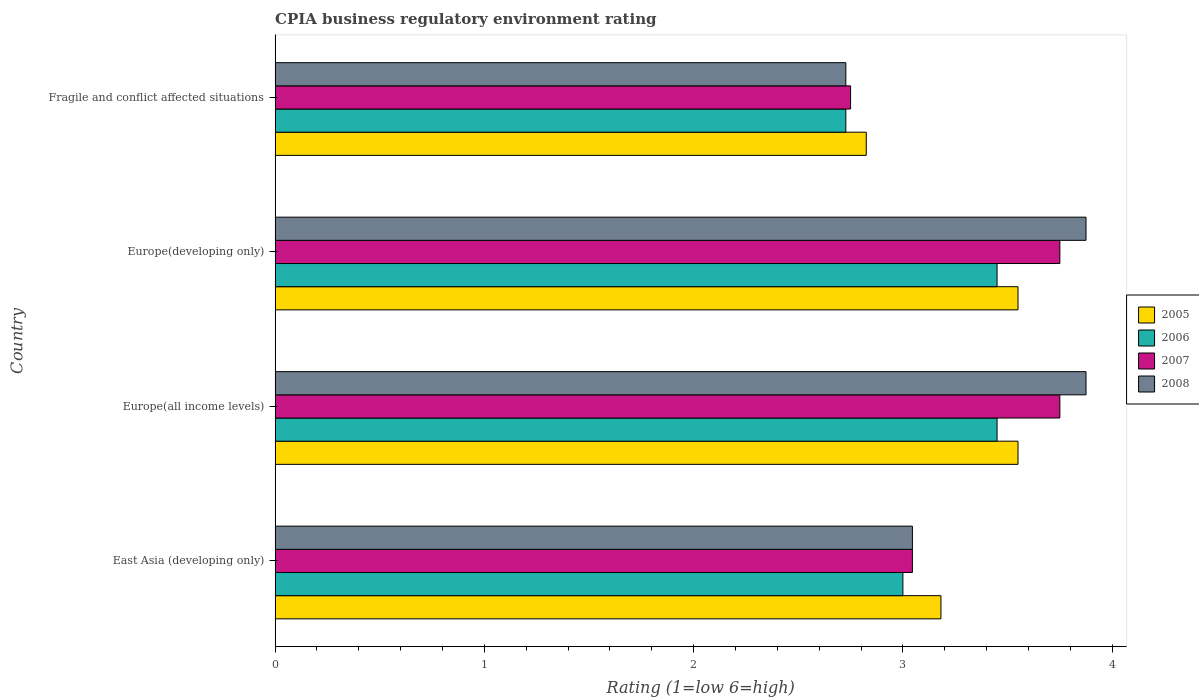How many different coloured bars are there?
Your response must be concise. 4. Are the number of bars on each tick of the Y-axis equal?
Offer a very short reply. Yes. What is the label of the 4th group of bars from the top?
Give a very brief answer. East Asia (developing only). In how many cases, is the number of bars for a given country not equal to the number of legend labels?
Ensure brevity in your answer.  0. What is the CPIA rating in 2008 in Europe(all income levels)?
Your response must be concise. 3.88. Across all countries, what is the maximum CPIA rating in 2007?
Provide a succinct answer. 3.75. Across all countries, what is the minimum CPIA rating in 2006?
Offer a terse response. 2.73. In which country was the CPIA rating in 2006 maximum?
Give a very brief answer. Europe(all income levels). In which country was the CPIA rating in 2005 minimum?
Your response must be concise. Fragile and conflict affected situations. What is the total CPIA rating in 2005 in the graph?
Ensure brevity in your answer.  13.11. What is the difference between the CPIA rating in 2008 in Europe(developing only) and that in Fragile and conflict affected situations?
Your response must be concise. 1.15. What is the average CPIA rating in 2006 per country?
Provide a short and direct response. 3.16. What is the difference between the CPIA rating in 2006 and CPIA rating in 2007 in East Asia (developing only)?
Keep it short and to the point. -0.05. In how many countries, is the CPIA rating in 2005 greater than 3.6 ?
Provide a succinct answer. 0. What is the ratio of the CPIA rating in 2007 in East Asia (developing only) to that in Europe(developing only)?
Offer a terse response. 0.81. Is the difference between the CPIA rating in 2006 in East Asia (developing only) and Fragile and conflict affected situations greater than the difference between the CPIA rating in 2007 in East Asia (developing only) and Fragile and conflict affected situations?
Provide a succinct answer. No. What is the difference between the highest and the lowest CPIA rating in 2006?
Your answer should be compact. 0.72. In how many countries, is the CPIA rating in 2007 greater than the average CPIA rating in 2007 taken over all countries?
Provide a succinct answer. 2. Is the sum of the CPIA rating in 2008 in East Asia (developing only) and Europe(all income levels) greater than the maximum CPIA rating in 2006 across all countries?
Offer a terse response. Yes. What does the 3rd bar from the bottom in Fragile and conflict affected situations represents?
Ensure brevity in your answer.  2007. Is it the case that in every country, the sum of the CPIA rating in 2008 and CPIA rating in 2007 is greater than the CPIA rating in 2006?
Give a very brief answer. Yes. How many bars are there?
Your answer should be compact. 16. How many countries are there in the graph?
Ensure brevity in your answer.  4. Where does the legend appear in the graph?
Your answer should be very brief. Center right. How many legend labels are there?
Your answer should be very brief. 4. What is the title of the graph?
Provide a succinct answer. CPIA business regulatory environment rating. What is the label or title of the X-axis?
Your response must be concise. Rating (1=low 6=high). What is the Rating (1=low 6=high) in 2005 in East Asia (developing only)?
Offer a terse response. 3.18. What is the Rating (1=low 6=high) of 2007 in East Asia (developing only)?
Your response must be concise. 3.05. What is the Rating (1=low 6=high) in 2008 in East Asia (developing only)?
Provide a succinct answer. 3.05. What is the Rating (1=low 6=high) in 2005 in Europe(all income levels)?
Keep it short and to the point. 3.55. What is the Rating (1=low 6=high) in 2006 in Europe(all income levels)?
Your response must be concise. 3.45. What is the Rating (1=low 6=high) of 2007 in Europe(all income levels)?
Keep it short and to the point. 3.75. What is the Rating (1=low 6=high) of 2008 in Europe(all income levels)?
Your response must be concise. 3.88. What is the Rating (1=low 6=high) of 2005 in Europe(developing only)?
Offer a very short reply. 3.55. What is the Rating (1=low 6=high) in 2006 in Europe(developing only)?
Ensure brevity in your answer.  3.45. What is the Rating (1=low 6=high) of 2007 in Europe(developing only)?
Your answer should be compact. 3.75. What is the Rating (1=low 6=high) of 2008 in Europe(developing only)?
Provide a succinct answer. 3.88. What is the Rating (1=low 6=high) in 2005 in Fragile and conflict affected situations?
Make the answer very short. 2.83. What is the Rating (1=low 6=high) of 2006 in Fragile and conflict affected situations?
Your answer should be very brief. 2.73. What is the Rating (1=low 6=high) of 2007 in Fragile and conflict affected situations?
Provide a short and direct response. 2.75. What is the Rating (1=low 6=high) in 2008 in Fragile and conflict affected situations?
Your answer should be compact. 2.73. Across all countries, what is the maximum Rating (1=low 6=high) in 2005?
Your response must be concise. 3.55. Across all countries, what is the maximum Rating (1=low 6=high) in 2006?
Your response must be concise. 3.45. Across all countries, what is the maximum Rating (1=low 6=high) of 2007?
Your answer should be very brief. 3.75. Across all countries, what is the maximum Rating (1=low 6=high) in 2008?
Offer a terse response. 3.88. Across all countries, what is the minimum Rating (1=low 6=high) of 2005?
Ensure brevity in your answer.  2.83. Across all countries, what is the minimum Rating (1=low 6=high) of 2006?
Your response must be concise. 2.73. Across all countries, what is the minimum Rating (1=low 6=high) in 2007?
Make the answer very short. 2.75. Across all countries, what is the minimum Rating (1=low 6=high) of 2008?
Give a very brief answer. 2.73. What is the total Rating (1=low 6=high) in 2005 in the graph?
Give a very brief answer. 13.11. What is the total Rating (1=low 6=high) of 2006 in the graph?
Keep it short and to the point. 12.63. What is the total Rating (1=low 6=high) of 2007 in the graph?
Your answer should be very brief. 13.3. What is the total Rating (1=low 6=high) of 2008 in the graph?
Your answer should be compact. 13.52. What is the difference between the Rating (1=low 6=high) of 2005 in East Asia (developing only) and that in Europe(all income levels)?
Your answer should be compact. -0.37. What is the difference between the Rating (1=low 6=high) of 2006 in East Asia (developing only) and that in Europe(all income levels)?
Give a very brief answer. -0.45. What is the difference between the Rating (1=low 6=high) of 2007 in East Asia (developing only) and that in Europe(all income levels)?
Your answer should be compact. -0.7. What is the difference between the Rating (1=low 6=high) of 2008 in East Asia (developing only) and that in Europe(all income levels)?
Offer a terse response. -0.83. What is the difference between the Rating (1=low 6=high) of 2005 in East Asia (developing only) and that in Europe(developing only)?
Ensure brevity in your answer.  -0.37. What is the difference between the Rating (1=low 6=high) of 2006 in East Asia (developing only) and that in Europe(developing only)?
Provide a succinct answer. -0.45. What is the difference between the Rating (1=low 6=high) of 2007 in East Asia (developing only) and that in Europe(developing only)?
Give a very brief answer. -0.7. What is the difference between the Rating (1=low 6=high) of 2008 in East Asia (developing only) and that in Europe(developing only)?
Give a very brief answer. -0.83. What is the difference between the Rating (1=low 6=high) in 2005 in East Asia (developing only) and that in Fragile and conflict affected situations?
Offer a terse response. 0.36. What is the difference between the Rating (1=low 6=high) in 2006 in East Asia (developing only) and that in Fragile and conflict affected situations?
Provide a short and direct response. 0.27. What is the difference between the Rating (1=low 6=high) of 2007 in East Asia (developing only) and that in Fragile and conflict affected situations?
Offer a very short reply. 0.3. What is the difference between the Rating (1=low 6=high) in 2008 in East Asia (developing only) and that in Fragile and conflict affected situations?
Give a very brief answer. 0.32. What is the difference between the Rating (1=low 6=high) of 2006 in Europe(all income levels) and that in Europe(developing only)?
Give a very brief answer. 0. What is the difference between the Rating (1=low 6=high) in 2007 in Europe(all income levels) and that in Europe(developing only)?
Your response must be concise. 0. What is the difference between the Rating (1=low 6=high) in 2005 in Europe(all income levels) and that in Fragile and conflict affected situations?
Provide a short and direct response. 0.72. What is the difference between the Rating (1=low 6=high) of 2006 in Europe(all income levels) and that in Fragile and conflict affected situations?
Make the answer very short. 0.72. What is the difference between the Rating (1=low 6=high) of 2007 in Europe(all income levels) and that in Fragile and conflict affected situations?
Your response must be concise. 1. What is the difference between the Rating (1=low 6=high) of 2008 in Europe(all income levels) and that in Fragile and conflict affected situations?
Offer a terse response. 1.15. What is the difference between the Rating (1=low 6=high) of 2005 in Europe(developing only) and that in Fragile and conflict affected situations?
Give a very brief answer. 0.72. What is the difference between the Rating (1=low 6=high) in 2006 in Europe(developing only) and that in Fragile and conflict affected situations?
Provide a succinct answer. 0.72. What is the difference between the Rating (1=low 6=high) in 2007 in Europe(developing only) and that in Fragile and conflict affected situations?
Keep it short and to the point. 1. What is the difference between the Rating (1=low 6=high) in 2008 in Europe(developing only) and that in Fragile and conflict affected situations?
Offer a terse response. 1.15. What is the difference between the Rating (1=low 6=high) of 2005 in East Asia (developing only) and the Rating (1=low 6=high) of 2006 in Europe(all income levels)?
Offer a terse response. -0.27. What is the difference between the Rating (1=low 6=high) of 2005 in East Asia (developing only) and the Rating (1=low 6=high) of 2007 in Europe(all income levels)?
Keep it short and to the point. -0.57. What is the difference between the Rating (1=low 6=high) in 2005 in East Asia (developing only) and the Rating (1=low 6=high) in 2008 in Europe(all income levels)?
Offer a very short reply. -0.69. What is the difference between the Rating (1=low 6=high) in 2006 in East Asia (developing only) and the Rating (1=low 6=high) in 2007 in Europe(all income levels)?
Your answer should be very brief. -0.75. What is the difference between the Rating (1=low 6=high) in 2006 in East Asia (developing only) and the Rating (1=low 6=high) in 2008 in Europe(all income levels)?
Keep it short and to the point. -0.88. What is the difference between the Rating (1=low 6=high) of 2007 in East Asia (developing only) and the Rating (1=low 6=high) of 2008 in Europe(all income levels)?
Your answer should be very brief. -0.83. What is the difference between the Rating (1=low 6=high) of 2005 in East Asia (developing only) and the Rating (1=low 6=high) of 2006 in Europe(developing only)?
Provide a succinct answer. -0.27. What is the difference between the Rating (1=low 6=high) of 2005 in East Asia (developing only) and the Rating (1=low 6=high) of 2007 in Europe(developing only)?
Make the answer very short. -0.57. What is the difference between the Rating (1=low 6=high) in 2005 in East Asia (developing only) and the Rating (1=low 6=high) in 2008 in Europe(developing only)?
Your response must be concise. -0.69. What is the difference between the Rating (1=low 6=high) of 2006 in East Asia (developing only) and the Rating (1=low 6=high) of 2007 in Europe(developing only)?
Your response must be concise. -0.75. What is the difference between the Rating (1=low 6=high) in 2006 in East Asia (developing only) and the Rating (1=low 6=high) in 2008 in Europe(developing only)?
Offer a very short reply. -0.88. What is the difference between the Rating (1=low 6=high) in 2007 in East Asia (developing only) and the Rating (1=low 6=high) in 2008 in Europe(developing only)?
Provide a succinct answer. -0.83. What is the difference between the Rating (1=low 6=high) in 2005 in East Asia (developing only) and the Rating (1=low 6=high) in 2006 in Fragile and conflict affected situations?
Your answer should be very brief. 0.45. What is the difference between the Rating (1=low 6=high) in 2005 in East Asia (developing only) and the Rating (1=low 6=high) in 2007 in Fragile and conflict affected situations?
Provide a succinct answer. 0.43. What is the difference between the Rating (1=low 6=high) of 2005 in East Asia (developing only) and the Rating (1=low 6=high) of 2008 in Fragile and conflict affected situations?
Provide a short and direct response. 0.45. What is the difference between the Rating (1=low 6=high) in 2006 in East Asia (developing only) and the Rating (1=low 6=high) in 2007 in Fragile and conflict affected situations?
Your answer should be compact. 0.25. What is the difference between the Rating (1=low 6=high) of 2006 in East Asia (developing only) and the Rating (1=low 6=high) of 2008 in Fragile and conflict affected situations?
Keep it short and to the point. 0.27. What is the difference between the Rating (1=low 6=high) of 2007 in East Asia (developing only) and the Rating (1=low 6=high) of 2008 in Fragile and conflict affected situations?
Your answer should be compact. 0.32. What is the difference between the Rating (1=low 6=high) in 2005 in Europe(all income levels) and the Rating (1=low 6=high) in 2006 in Europe(developing only)?
Ensure brevity in your answer.  0.1. What is the difference between the Rating (1=low 6=high) in 2005 in Europe(all income levels) and the Rating (1=low 6=high) in 2008 in Europe(developing only)?
Offer a very short reply. -0.33. What is the difference between the Rating (1=low 6=high) in 2006 in Europe(all income levels) and the Rating (1=low 6=high) in 2007 in Europe(developing only)?
Your answer should be compact. -0.3. What is the difference between the Rating (1=low 6=high) of 2006 in Europe(all income levels) and the Rating (1=low 6=high) of 2008 in Europe(developing only)?
Give a very brief answer. -0.42. What is the difference between the Rating (1=low 6=high) in 2007 in Europe(all income levels) and the Rating (1=low 6=high) in 2008 in Europe(developing only)?
Provide a short and direct response. -0.12. What is the difference between the Rating (1=low 6=high) in 2005 in Europe(all income levels) and the Rating (1=low 6=high) in 2006 in Fragile and conflict affected situations?
Ensure brevity in your answer.  0.82. What is the difference between the Rating (1=low 6=high) of 2005 in Europe(all income levels) and the Rating (1=low 6=high) of 2008 in Fragile and conflict affected situations?
Your response must be concise. 0.82. What is the difference between the Rating (1=low 6=high) in 2006 in Europe(all income levels) and the Rating (1=low 6=high) in 2008 in Fragile and conflict affected situations?
Provide a short and direct response. 0.72. What is the difference between the Rating (1=low 6=high) in 2007 in Europe(all income levels) and the Rating (1=low 6=high) in 2008 in Fragile and conflict affected situations?
Ensure brevity in your answer.  1.02. What is the difference between the Rating (1=low 6=high) in 2005 in Europe(developing only) and the Rating (1=low 6=high) in 2006 in Fragile and conflict affected situations?
Offer a terse response. 0.82. What is the difference between the Rating (1=low 6=high) of 2005 in Europe(developing only) and the Rating (1=low 6=high) of 2007 in Fragile and conflict affected situations?
Your answer should be compact. 0.8. What is the difference between the Rating (1=low 6=high) in 2005 in Europe(developing only) and the Rating (1=low 6=high) in 2008 in Fragile and conflict affected situations?
Your response must be concise. 0.82. What is the difference between the Rating (1=low 6=high) of 2006 in Europe(developing only) and the Rating (1=low 6=high) of 2007 in Fragile and conflict affected situations?
Your answer should be very brief. 0.7. What is the difference between the Rating (1=low 6=high) of 2006 in Europe(developing only) and the Rating (1=low 6=high) of 2008 in Fragile and conflict affected situations?
Provide a short and direct response. 0.72. What is the difference between the Rating (1=low 6=high) of 2007 in Europe(developing only) and the Rating (1=low 6=high) of 2008 in Fragile and conflict affected situations?
Give a very brief answer. 1.02. What is the average Rating (1=low 6=high) in 2005 per country?
Keep it short and to the point. 3.28. What is the average Rating (1=low 6=high) in 2006 per country?
Make the answer very short. 3.16. What is the average Rating (1=low 6=high) in 2007 per country?
Your answer should be compact. 3.32. What is the average Rating (1=low 6=high) in 2008 per country?
Make the answer very short. 3.38. What is the difference between the Rating (1=low 6=high) of 2005 and Rating (1=low 6=high) of 2006 in East Asia (developing only)?
Offer a terse response. 0.18. What is the difference between the Rating (1=low 6=high) in 2005 and Rating (1=low 6=high) in 2007 in East Asia (developing only)?
Give a very brief answer. 0.14. What is the difference between the Rating (1=low 6=high) in 2005 and Rating (1=low 6=high) in 2008 in East Asia (developing only)?
Your answer should be compact. 0.14. What is the difference between the Rating (1=low 6=high) of 2006 and Rating (1=low 6=high) of 2007 in East Asia (developing only)?
Provide a succinct answer. -0.05. What is the difference between the Rating (1=low 6=high) in 2006 and Rating (1=low 6=high) in 2008 in East Asia (developing only)?
Give a very brief answer. -0.05. What is the difference between the Rating (1=low 6=high) in 2007 and Rating (1=low 6=high) in 2008 in East Asia (developing only)?
Offer a terse response. 0. What is the difference between the Rating (1=low 6=high) of 2005 and Rating (1=low 6=high) of 2008 in Europe(all income levels)?
Your response must be concise. -0.33. What is the difference between the Rating (1=low 6=high) of 2006 and Rating (1=low 6=high) of 2007 in Europe(all income levels)?
Offer a terse response. -0.3. What is the difference between the Rating (1=low 6=high) of 2006 and Rating (1=low 6=high) of 2008 in Europe(all income levels)?
Offer a terse response. -0.42. What is the difference between the Rating (1=low 6=high) of 2007 and Rating (1=low 6=high) of 2008 in Europe(all income levels)?
Provide a succinct answer. -0.12. What is the difference between the Rating (1=low 6=high) in 2005 and Rating (1=low 6=high) in 2007 in Europe(developing only)?
Your answer should be very brief. -0.2. What is the difference between the Rating (1=low 6=high) in 2005 and Rating (1=low 6=high) in 2008 in Europe(developing only)?
Provide a short and direct response. -0.33. What is the difference between the Rating (1=low 6=high) in 2006 and Rating (1=low 6=high) in 2007 in Europe(developing only)?
Provide a succinct answer. -0.3. What is the difference between the Rating (1=low 6=high) of 2006 and Rating (1=low 6=high) of 2008 in Europe(developing only)?
Give a very brief answer. -0.42. What is the difference between the Rating (1=low 6=high) of 2007 and Rating (1=low 6=high) of 2008 in Europe(developing only)?
Your response must be concise. -0.12. What is the difference between the Rating (1=low 6=high) in 2005 and Rating (1=low 6=high) in 2006 in Fragile and conflict affected situations?
Offer a terse response. 0.1. What is the difference between the Rating (1=low 6=high) of 2005 and Rating (1=low 6=high) of 2007 in Fragile and conflict affected situations?
Provide a short and direct response. 0.07. What is the difference between the Rating (1=low 6=high) in 2005 and Rating (1=low 6=high) in 2008 in Fragile and conflict affected situations?
Offer a very short reply. 0.1. What is the difference between the Rating (1=low 6=high) of 2006 and Rating (1=low 6=high) of 2007 in Fragile and conflict affected situations?
Ensure brevity in your answer.  -0.02. What is the difference between the Rating (1=low 6=high) of 2006 and Rating (1=low 6=high) of 2008 in Fragile and conflict affected situations?
Provide a short and direct response. 0. What is the difference between the Rating (1=low 6=high) in 2007 and Rating (1=low 6=high) in 2008 in Fragile and conflict affected situations?
Ensure brevity in your answer.  0.02. What is the ratio of the Rating (1=low 6=high) in 2005 in East Asia (developing only) to that in Europe(all income levels)?
Your answer should be compact. 0.9. What is the ratio of the Rating (1=low 6=high) of 2006 in East Asia (developing only) to that in Europe(all income levels)?
Your answer should be compact. 0.87. What is the ratio of the Rating (1=low 6=high) of 2007 in East Asia (developing only) to that in Europe(all income levels)?
Make the answer very short. 0.81. What is the ratio of the Rating (1=low 6=high) in 2008 in East Asia (developing only) to that in Europe(all income levels)?
Your answer should be compact. 0.79. What is the ratio of the Rating (1=low 6=high) in 2005 in East Asia (developing only) to that in Europe(developing only)?
Provide a succinct answer. 0.9. What is the ratio of the Rating (1=low 6=high) of 2006 in East Asia (developing only) to that in Europe(developing only)?
Give a very brief answer. 0.87. What is the ratio of the Rating (1=low 6=high) in 2007 in East Asia (developing only) to that in Europe(developing only)?
Offer a terse response. 0.81. What is the ratio of the Rating (1=low 6=high) in 2008 in East Asia (developing only) to that in Europe(developing only)?
Your answer should be very brief. 0.79. What is the ratio of the Rating (1=low 6=high) in 2005 in East Asia (developing only) to that in Fragile and conflict affected situations?
Ensure brevity in your answer.  1.13. What is the ratio of the Rating (1=low 6=high) in 2007 in East Asia (developing only) to that in Fragile and conflict affected situations?
Provide a succinct answer. 1.11. What is the ratio of the Rating (1=low 6=high) of 2008 in East Asia (developing only) to that in Fragile and conflict affected situations?
Your answer should be very brief. 1.12. What is the ratio of the Rating (1=low 6=high) in 2006 in Europe(all income levels) to that in Europe(developing only)?
Ensure brevity in your answer.  1. What is the ratio of the Rating (1=low 6=high) in 2005 in Europe(all income levels) to that in Fragile and conflict affected situations?
Give a very brief answer. 1.26. What is the ratio of the Rating (1=low 6=high) in 2006 in Europe(all income levels) to that in Fragile and conflict affected situations?
Ensure brevity in your answer.  1.26. What is the ratio of the Rating (1=low 6=high) of 2007 in Europe(all income levels) to that in Fragile and conflict affected situations?
Offer a terse response. 1.36. What is the ratio of the Rating (1=low 6=high) in 2008 in Europe(all income levels) to that in Fragile and conflict affected situations?
Ensure brevity in your answer.  1.42. What is the ratio of the Rating (1=low 6=high) in 2005 in Europe(developing only) to that in Fragile and conflict affected situations?
Ensure brevity in your answer.  1.26. What is the ratio of the Rating (1=low 6=high) in 2006 in Europe(developing only) to that in Fragile and conflict affected situations?
Ensure brevity in your answer.  1.26. What is the ratio of the Rating (1=low 6=high) of 2007 in Europe(developing only) to that in Fragile and conflict affected situations?
Keep it short and to the point. 1.36. What is the ratio of the Rating (1=low 6=high) in 2008 in Europe(developing only) to that in Fragile and conflict affected situations?
Your answer should be very brief. 1.42. What is the difference between the highest and the second highest Rating (1=low 6=high) of 2007?
Your answer should be very brief. 0. What is the difference between the highest and the second highest Rating (1=low 6=high) of 2008?
Provide a short and direct response. 0. What is the difference between the highest and the lowest Rating (1=low 6=high) of 2005?
Your answer should be compact. 0.72. What is the difference between the highest and the lowest Rating (1=low 6=high) of 2006?
Make the answer very short. 0.72. What is the difference between the highest and the lowest Rating (1=low 6=high) in 2007?
Your answer should be very brief. 1. What is the difference between the highest and the lowest Rating (1=low 6=high) of 2008?
Ensure brevity in your answer.  1.15. 